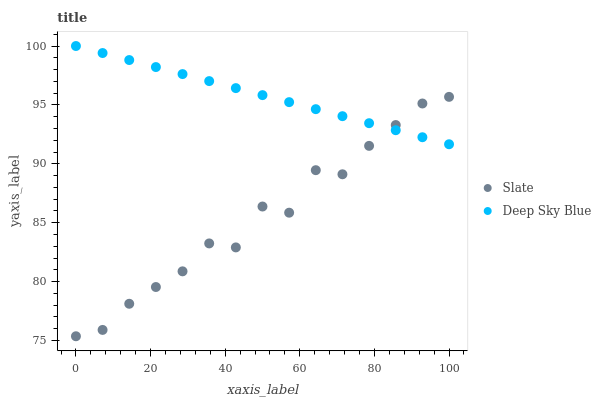Does Slate have the minimum area under the curve?
Answer yes or no. Yes. Does Deep Sky Blue have the maximum area under the curve?
Answer yes or no. Yes. Does Deep Sky Blue have the minimum area under the curve?
Answer yes or no. No. Is Deep Sky Blue the smoothest?
Answer yes or no. Yes. Is Slate the roughest?
Answer yes or no. Yes. Is Deep Sky Blue the roughest?
Answer yes or no. No. Does Slate have the lowest value?
Answer yes or no. Yes. Does Deep Sky Blue have the lowest value?
Answer yes or no. No. Does Deep Sky Blue have the highest value?
Answer yes or no. Yes. Does Deep Sky Blue intersect Slate?
Answer yes or no. Yes. Is Deep Sky Blue less than Slate?
Answer yes or no. No. Is Deep Sky Blue greater than Slate?
Answer yes or no. No. 